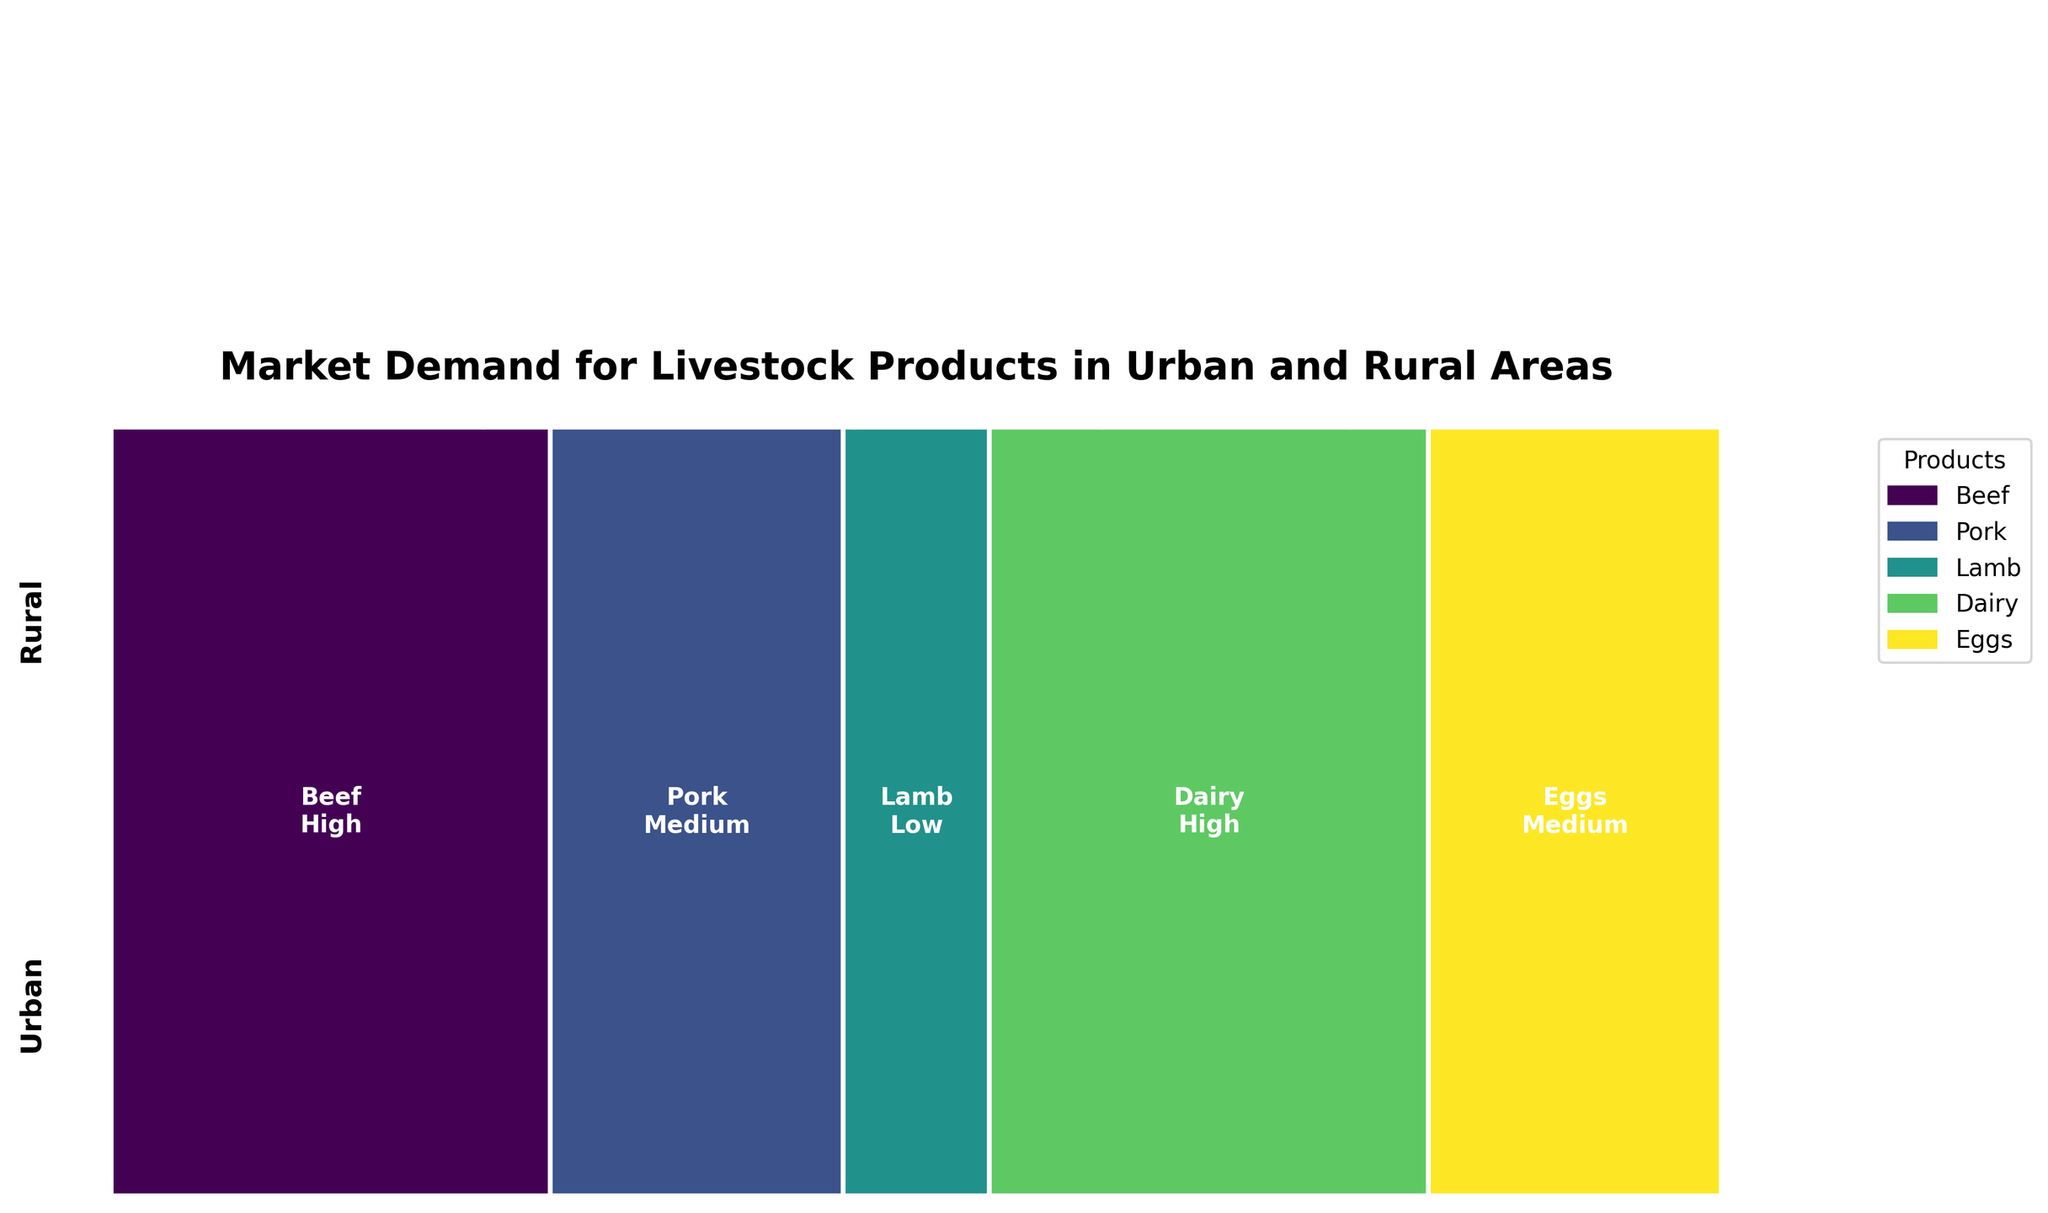Which area has a higher demand for beef? By looking at the size of the rectangles representing beef demand, the rectangles in both urban and rural areas are the same in size. However, considering the labels, both areas have high demand for beef.
Answer: Both Which product has the lowest demand in urban areas? In the urban section, the smallest rectangle corresponds to the lamb product, which is labeled as having low demand.
Answer: Lamb How does the demand for pork in rural areas compare to that in urban areas? For pork, the rectangle in the rural area shows a wider section labeled as high, while the urban rectangle for pork is smaller and labeled medium, indicating higher demand in rural areas.
Answer: Higher in rural Is there any product with a medium demand level in both areas? By comparing the labels, pork has a medium demand in urban but high in rural. Dairy has high in urban and medium in rural. Lamb has low in urban and medium in rural. So, none of the products have medium demand in both areas.
Answer: No Which area shows a higher demand for dairy products? Comparing the dairy rectangles, the urban area label for dairy is high, while the rural area label for dairy is medium. This means urban has higher demand for dairy products.
Answer: Urban Which two products have a high demand in rural areas? Observing the labels in the rural area section, beef and pork are both marked as high in demand.
Answer: Beef and Pork What is the combined demand of lamb and eggs in urban areas? The lamb product is labeled low and the eggs product is labeled medium in urban areas. Considering the values as Low (1), Medium (2), and High (3), the combined demand can be calculated: 1 (lamb) + 2 (eggs) = 3.
Answer: 3 How does the urban demand for eggs compare to the rural demand for eggs? Looking at the eggs section, urban demand is labeled medium whereas rural demand is labeled high. Thus, rural demand for eggs is higher.
Answer: Lower in urban What are the main differences in livestock product demand between urban and rural areas? Urban areas have high demand for beef and dairy, medium for pork and eggs, and low for lamb. Rural areas have high demand for beef, pork, and eggs; medium demand for lamb and dairy.
Answer: High: Urban - beef and dairy; Rural - beef, pork, and eggs. Medium: Urban - pork and eggs; Rural - lamb and dairy. Low: Urban - lamb Which area has a uniform demand across more products? In urban areas, two products (beef and dairy) have high demand and two products (pork and eggs) have medium demand. Rural areas have three products (beef, pork, eggs) with high demand. Therefore, rural areas have a more uniform high demand across different products.
Answer: Rural 